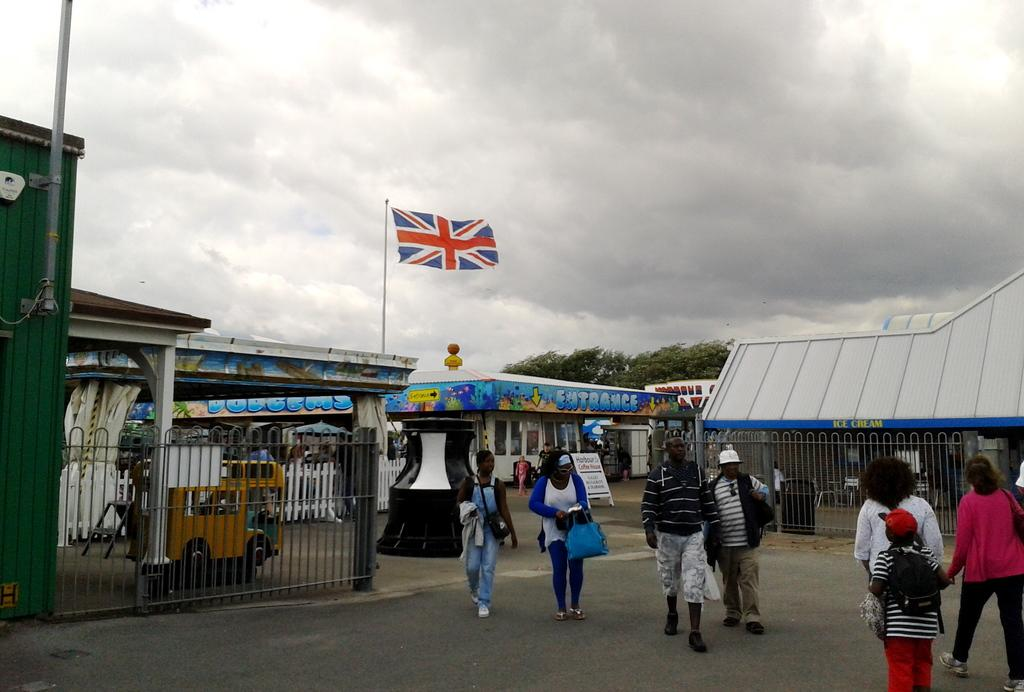<image>
Summarize the visual content of the image. Several people walking away from the entrance booth of a festival in the UK. 